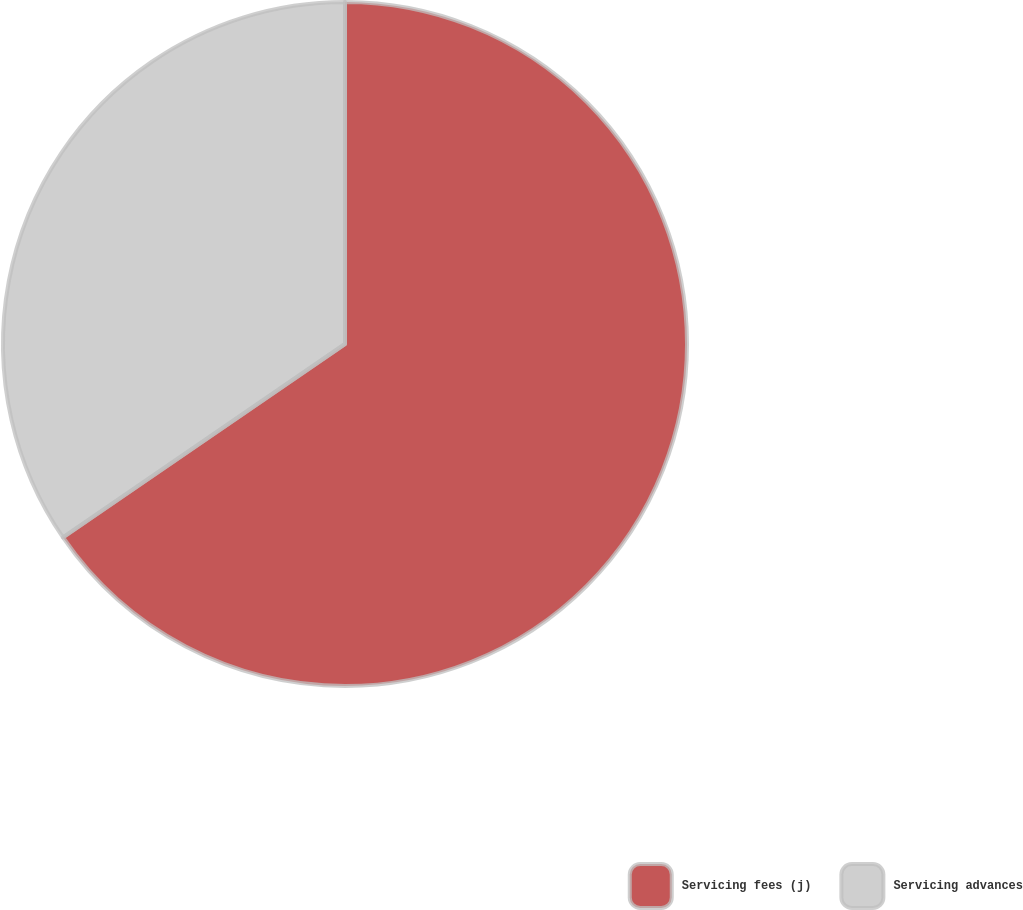<chart> <loc_0><loc_0><loc_500><loc_500><pie_chart><fcel>Servicing fees (j)<fcel>Servicing advances<nl><fcel>65.43%<fcel>34.57%<nl></chart> 